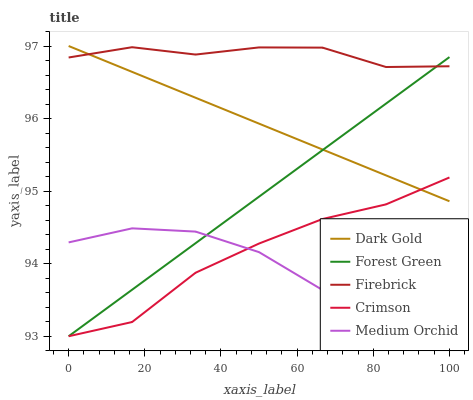Does Medium Orchid have the minimum area under the curve?
Answer yes or no. Yes. Does Firebrick have the maximum area under the curve?
Answer yes or no. Yes. Does Forest Green have the minimum area under the curve?
Answer yes or no. No. Does Forest Green have the maximum area under the curve?
Answer yes or no. No. Is Dark Gold the smoothest?
Answer yes or no. Yes. Is Medium Orchid the roughest?
Answer yes or no. Yes. Is Forest Green the smoothest?
Answer yes or no. No. Is Forest Green the roughest?
Answer yes or no. No. Does Crimson have the lowest value?
Answer yes or no. Yes. Does Firebrick have the lowest value?
Answer yes or no. No. Does Dark Gold have the highest value?
Answer yes or no. Yes. Does Forest Green have the highest value?
Answer yes or no. No. Is Medium Orchid less than Firebrick?
Answer yes or no. Yes. Is Firebrick greater than Medium Orchid?
Answer yes or no. Yes. Does Forest Green intersect Firebrick?
Answer yes or no. Yes. Is Forest Green less than Firebrick?
Answer yes or no. No. Is Forest Green greater than Firebrick?
Answer yes or no. No. Does Medium Orchid intersect Firebrick?
Answer yes or no. No. 